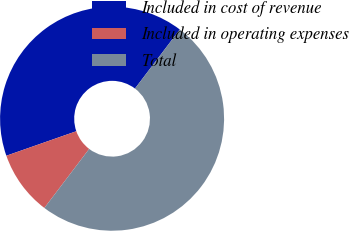Convert chart. <chart><loc_0><loc_0><loc_500><loc_500><pie_chart><fcel>Included in cost of revenue<fcel>Included in operating expenses<fcel>Total<nl><fcel>40.69%<fcel>9.31%<fcel>50.0%<nl></chart> 